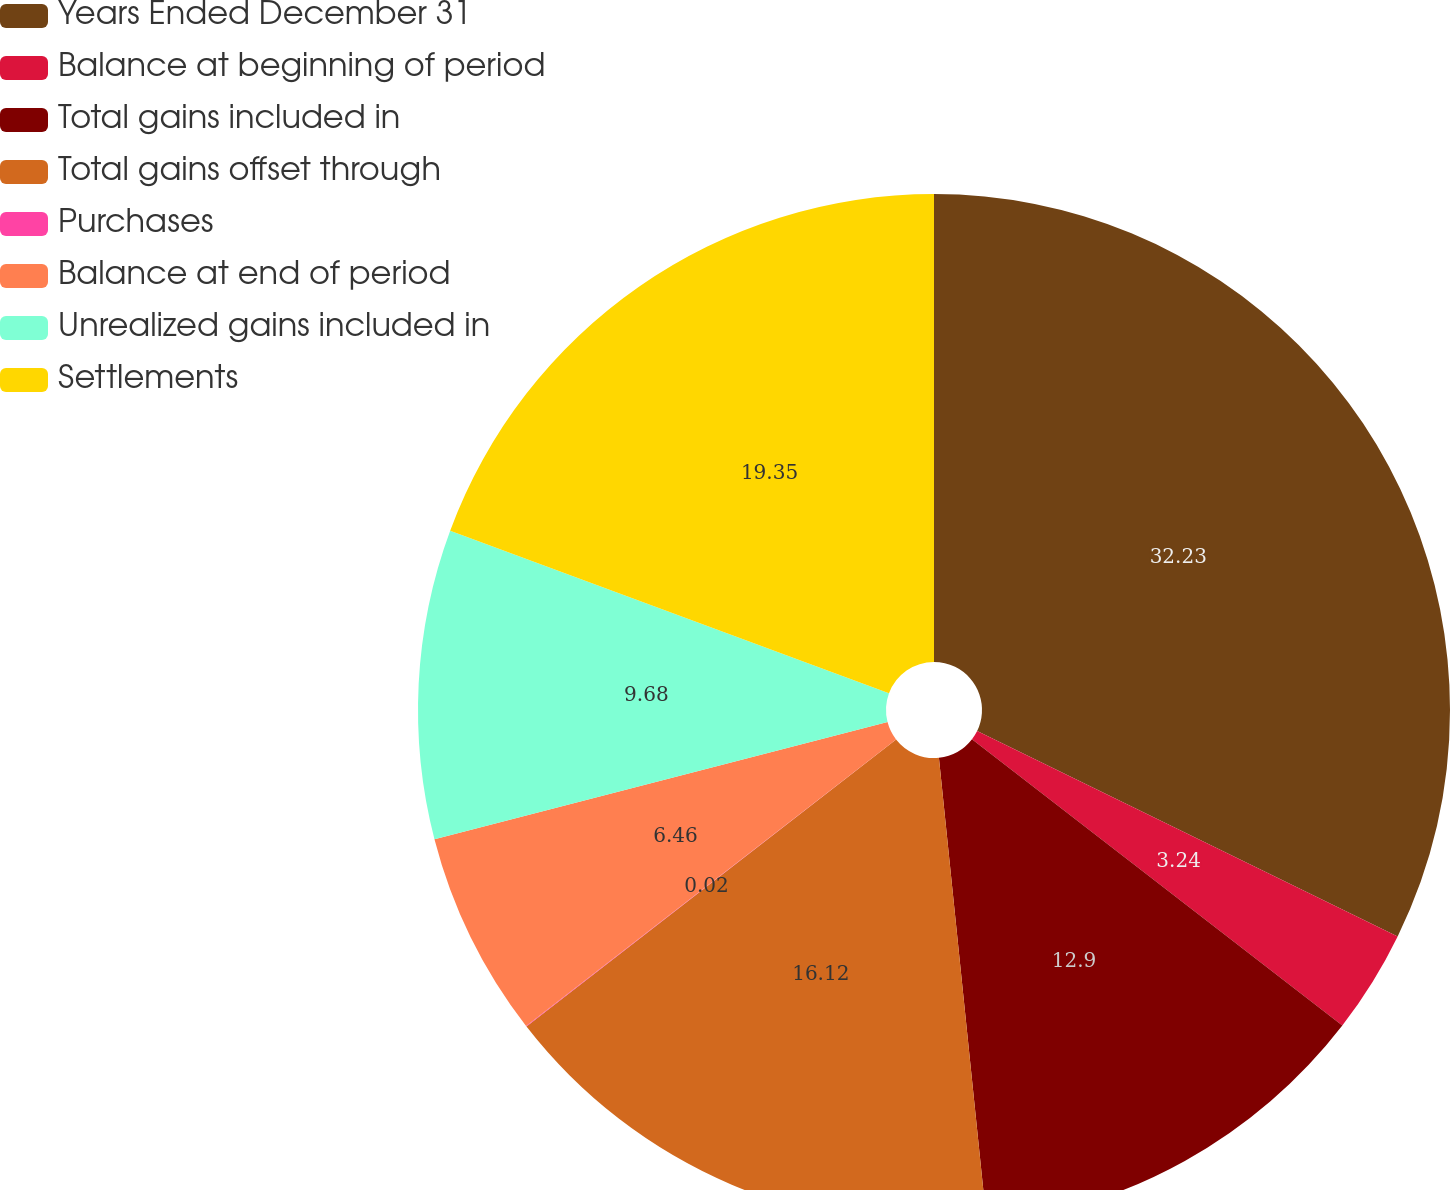<chart> <loc_0><loc_0><loc_500><loc_500><pie_chart><fcel>Years Ended December 31<fcel>Balance at beginning of period<fcel>Total gains included in<fcel>Total gains offset through<fcel>Purchases<fcel>Balance at end of period<fcel>Unrealized gains included in<fcel>Settlements<nl><fcel>32.23%<fcel>3.24%<fcel>12.9%<fcel>16.12%<fcel>0.02%<fcel>6.46%<fcel>9.68%<fcel>19.35%<nl></chart> 